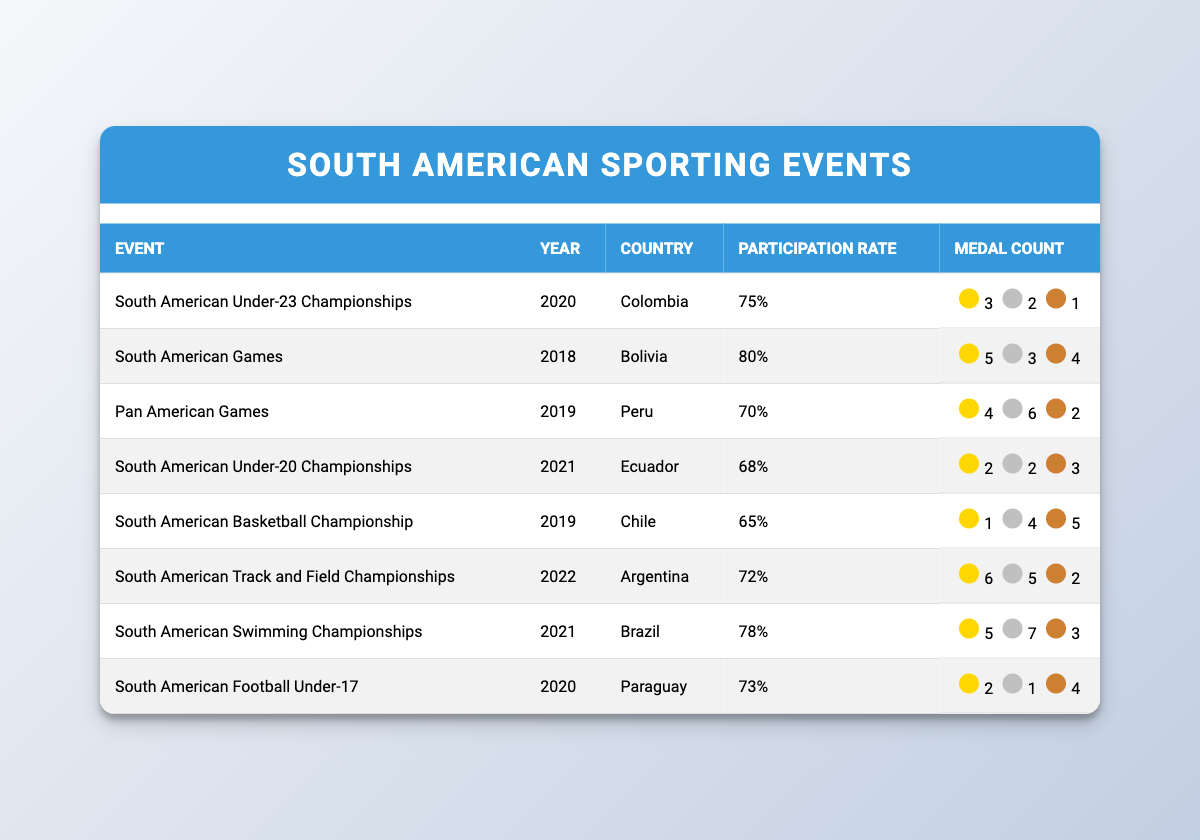What was the participation rate for the South American Under-23 Championships in 2020? The table indicates that the South American Under-23 Championships, held in 2020 in Colombia, had a participation rate of 75%.
Answer: 75% Which event had the highest number of gold medals? Looking through the medal counts, the South American Track and Field Championships in 2022 had the highest number of gold medals with 6.
Answer: 6 How many total medals did Brazil win in the South American Swimming Championships in 2021? The table shows Brazil won 5 gold, 7 silver, and 3 bronze medals at the South American Swimming Championships. Adding these gives a total of 5 + 7 + 3 = 15 medals.
Answer: 15 Did Paraguay win more silver or bronze medals in the South American Football Under-17 in 2020? Paraguay won 1 silver medal and 4 bronze medals in this event. Since 4 is greater than 1, Paraguay won more bronze medals.
Answer: No What is the average participation rate of the events listed in the table? The participation rates are 75, 80, 70, 68, 65, 72, 78, and 73. Summing these gives a total of 75 + 80 + 70 + 68 + 65 + 72 + 78 + 73 = 586. There are 8 events, so the average is 586 / 8 = 73.25.
Answer: 73.25 Which country had the least participation rate and what was it? By reviewing the participation rates in the table, the South American Basketball Championship in 2019 had the lowest participation rate of 65%.
Answer: 65% How many more gold medals did Argentina win compared to Chile in the South American events listed? Argentina won 6 gold medals in the South American Track and Field Championships while Chile won 1 gold medal in the South American Basketball Championship. The difference is 6 - 1 = 5.
Answer: 5 Was the South American Games in Bolivia in 2018 the only event with an 80% participation rate? Looking at the table, the South American Games is indeed the only event listed with an 80% participation rate, as all other rates are different.
Answer: Yes 